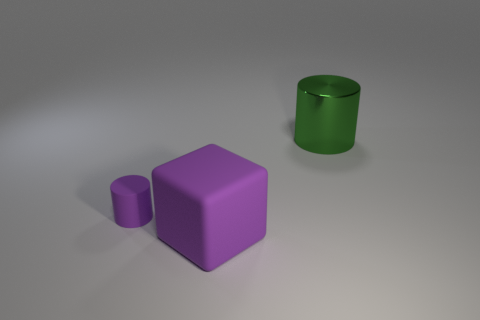What materials do the objects in the image appear to be made from? The objects in the image appear to have a matte finish. The cube and the cylinder likely represent objects with a solid matte surface, possibly simulating a plastic or painted metal texture. 